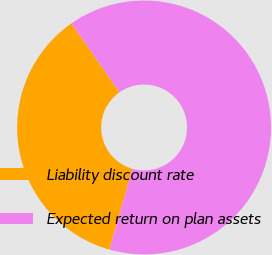Convert chart. <chart><loc_0><loc_0><loc_500><loc_500><pie_chart><fcel>Liability discount rate<fcel>Expected return on plan assets<nl><fcel>35.9%<fcel>64.1%<nl></chart> 